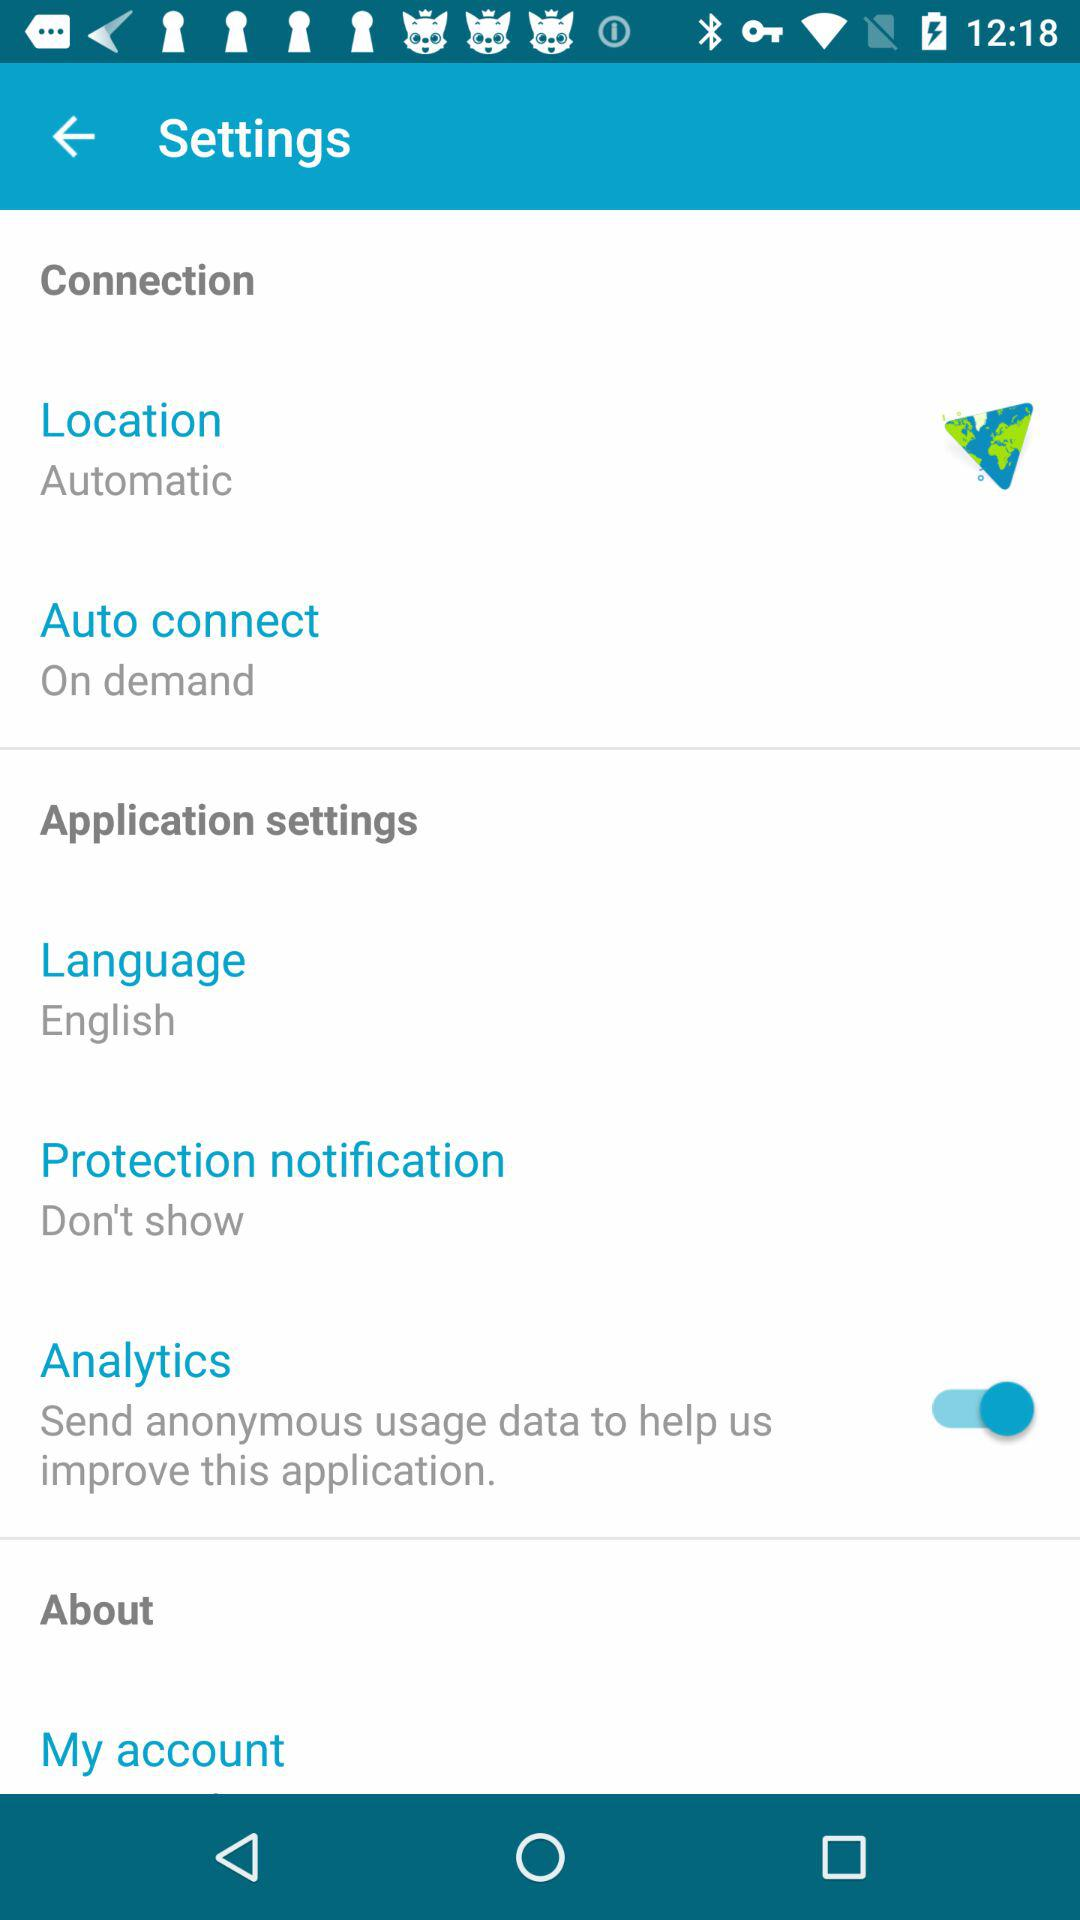What is the status of the "Analytics"? The status is "on". 